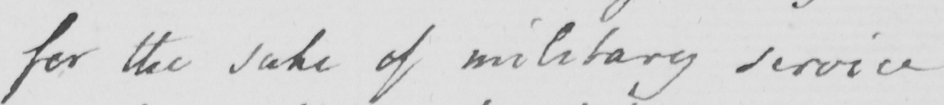Can you read and transcribe this handwriting? for the sake of military service 